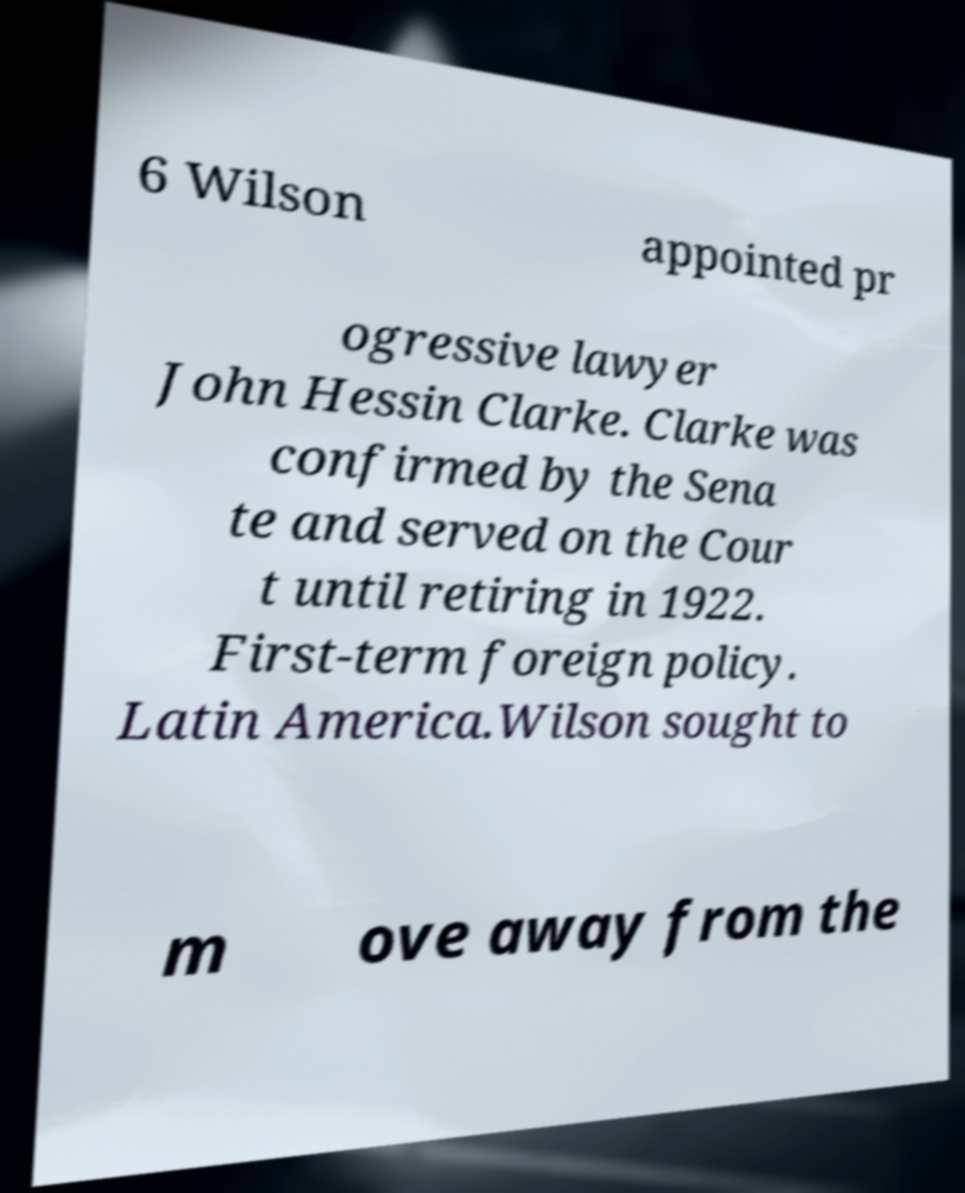There's text embedded in this image that I need extracted. Can you transcribe it verbatim? 6 Wilson appointed pr ogressive lawyer John Hessin Clarke. Clarke was confirmed by the Sena te and served on the Cour t until retiring in 1922. First-term foreign policy. Latin America.Wilson sought to m ove away from the 